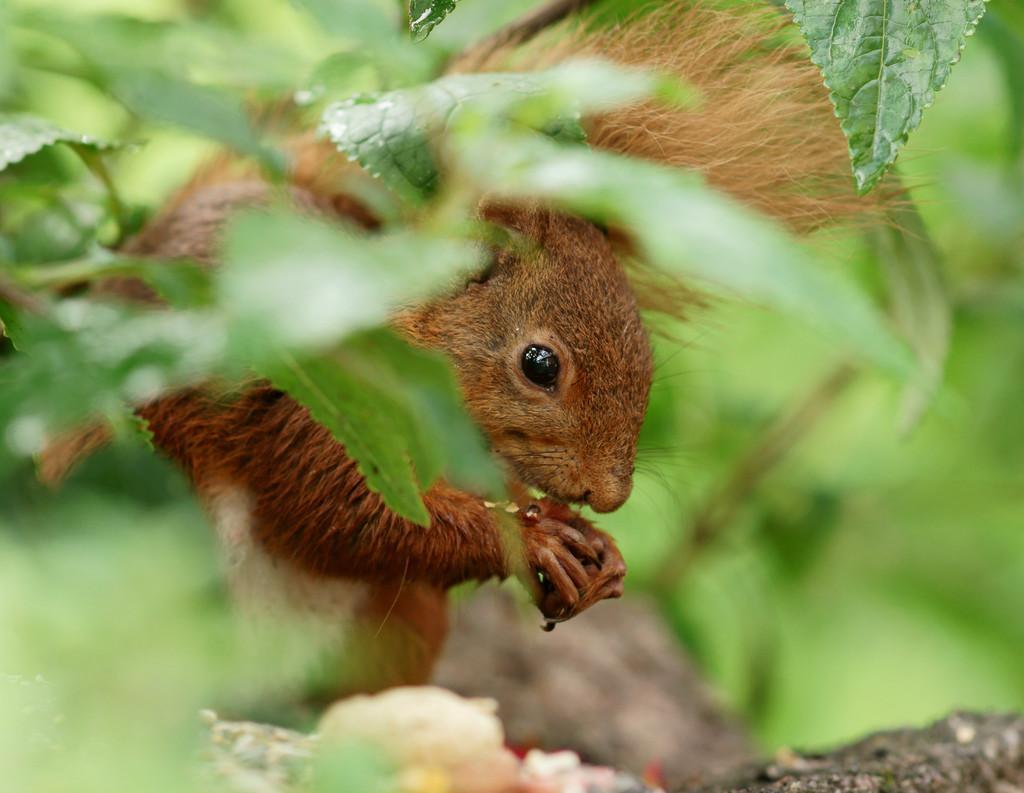How would you summarize this image in a sentence or two? This image is taken outdoors. In this image the background is green in color and it is a little blurred. There are many green leaves and stems. In the middle of the image there is a squirrel on the ground. 